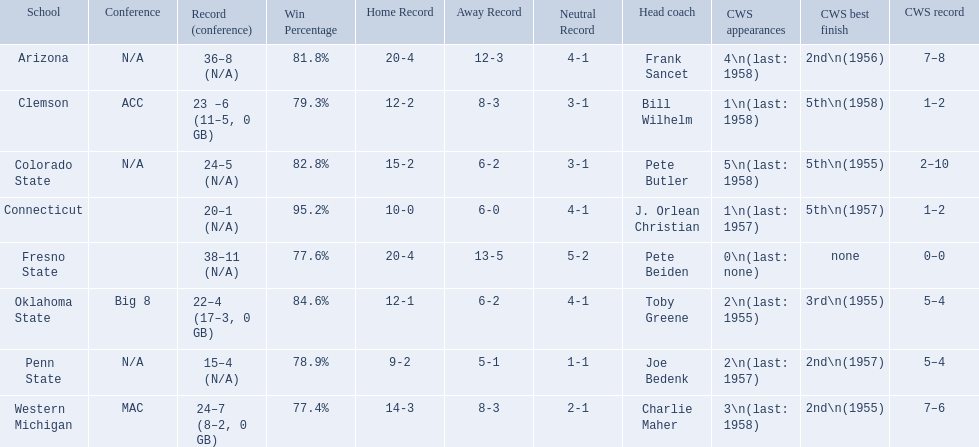What are all the school names? Arizona, Clemson, Colorado State, Connecticut, Fresno State, Oklahoma State, Penn State, Western Michigan. What is the record for each? 36–8 (N/A), 23 –6 (11–5, 0 GB), 24–5 (N/A), 20–1 (N/A), 38–11 (N/A), 22–4 (17–3, 0 GB), 15–4 (N/A), 24–7 (8–2, 0 GB). Which school had the fewest number of wins? Penn State. How many cws appearances does clemson have? 1\n(last: 1958). How many cws appearances does western michigan have? 3\n(last: 1958). Which of these schools has more cws appearances? Western Michigan. 